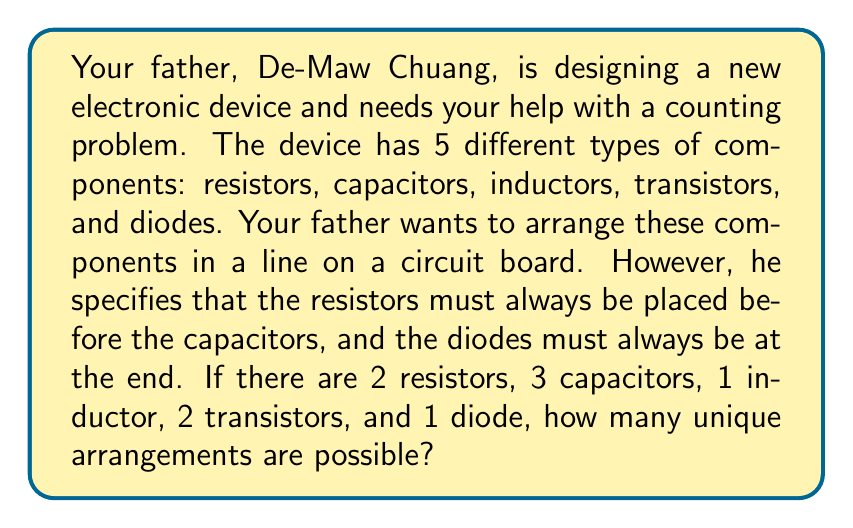What is the answer to this math problem? Let's approach this step-by-step:

1) First, we need to consider the constraints:
   - Resistors must be before capacitors
   - Diodes must be at the end

2) Given these constraints, we can think of the arrangement as having four sections:
   [Resistors] [Capacitors] [Inductors and Transistors] [Diode]

3) The resistors and capacitors form a block, and we need to arrange them within this block:
   - There are 2 resistors and 3 capacitors
   - This is equivalent to choosing 2 positions out of 5 for the resistors (or 3 positions for the capacitors)
   - This can be calculated using the combination formula: $\binom{5}{2}$ or $\binom{5}{3}$

   $$\binom{5}{2} = \frac{5!}{2!(5-2)!} = \frac{5 \cdot 4}{2 \cdot 1} = 10$$

4) Now, we need to arrange the inductor and transistors:
   - There are 3 components (1 inductor and 2 transistors) to arrange
   - This is a straightforward permutation: $3! = 3 \cdot 2 \cdot 1 = 6$

5) The diode is always at the end, so it doesn't affect our calculation.

6) By the multiplication principle, the total number of arrangements is:
   $10 \cdot 6 = 60$

Therefore, there are 60 unique arrangements possible.
Answer: 60 unique arrangements 